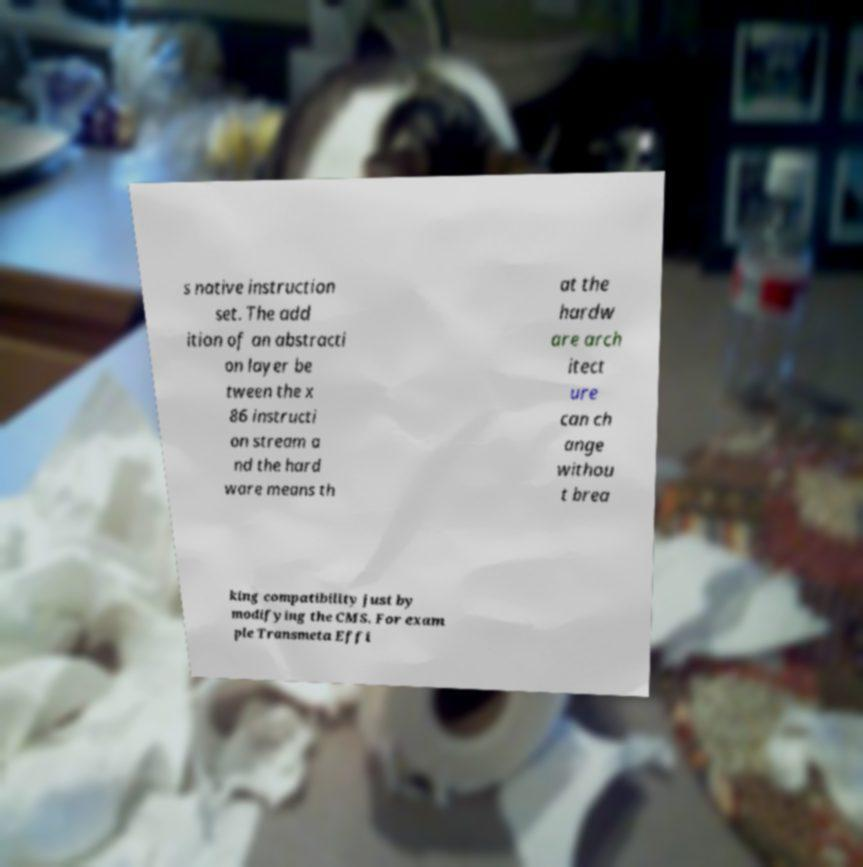What messages or text are displayed in this image? I need them in a readable, typed format. s native instruction set. The add ition of an abstracti on layer be tween the x 86 instructi on stream a nd the hard ware means th at the hardw are arch itect ure can ch ange withou t brea king compatibility just by modifying the CMS. For exam ple Transmeta Effi 